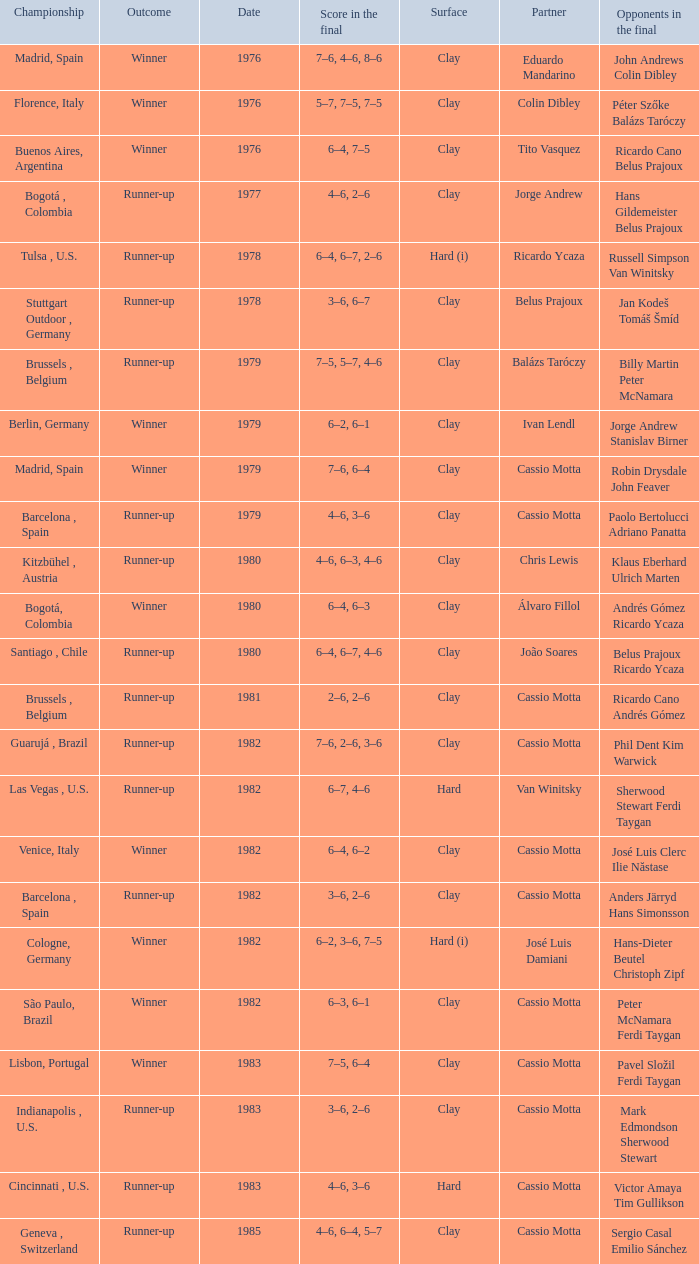What was the surface in 1981? Clay. 